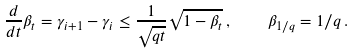<formula> <loc_0><loc_0><loc_500><loc_500>\frac { d } { d t } \beta _ { t } = \gamma _ { i + 1 } - \gamma _ { i } \leq \frac { 1 } { \sqrt { q t } } \sqrt { 1 - \beta _ { t } } \, , \quad \beta _ { 1 / q } = 1 / q \, .</formula> 